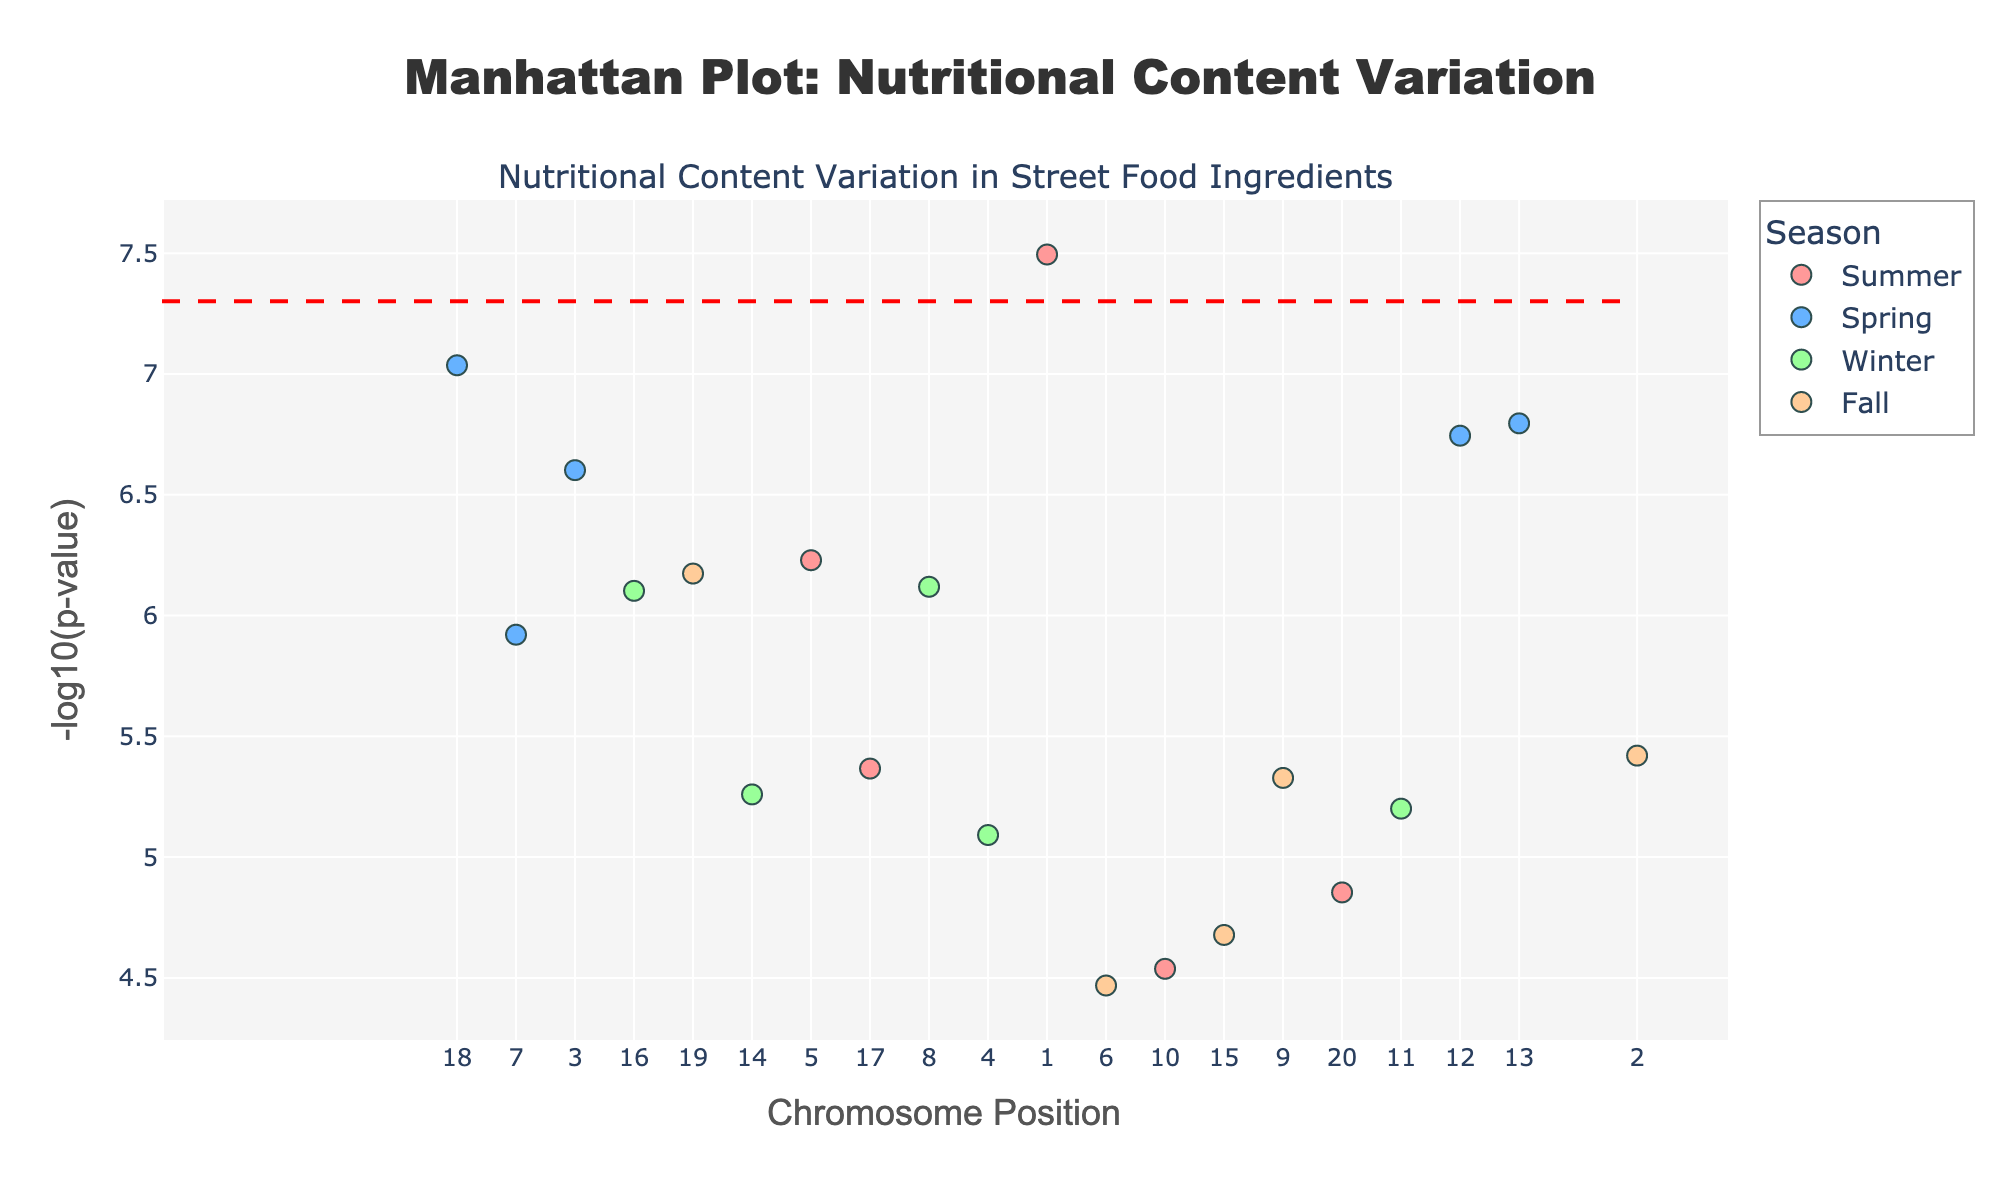How is the data categorized by seasons in the plot? The plot categorizes the data by seasons and assigns different colors to each season. This helps in visually distinguishing the data points of Tomatoes, Lettuce, Onions, etc., across Summer, Spring, Winter, and Fall.
Answer: By colors What is the highest -log10(p-value) observed in the plot and for which ingredient? The highest -log10(p-value) is the data point that appears highest on the y-axis of the plot. Observing the plot, this highest point corresponds to Tomatoes in Summer.
Answer: Tomatoes Which season has the most significant variation (lowest p-value) in nutritional content? The significance of variation is determined by the p-value, with lower p-values being more significant. Observing the plot, the lowest p-value corresponds to Tomatoes in Summer, and summer data points appear more frequently among the highly significant points.
Answer: Summer What does the red dashed line on the plot represent? The red dashed line is typically a significance threshold in Manhattan plots, indicating the p-value below which points are considered to be statistically significant. The plot shows this threshold line at -log10(5e-8).
Answer: Significance threshold How does the significance of the variation of Garlic in Spring compare to Cilantro in Fall? By comparing the heights of the points representing Garlic in Spring and Cilantro in Fall, we can see that Garlic in Spring (higher -log10(p-value)) is more significant than Cilantro in Fall (lower -log10(p-value)).
Answer: Garlic in Spring What is the total number of ingredients that exceed the significance threshold? Points exceeding the significance threshold can be counted visually above the red dashed line. By counting these points in the plot, we can observe how much of the nutritional variation is significant.
Answer: 3 ingredients Which season has the fewest data points? Each point on the plot is color-coded by season. By counting the number of points for each color, we can determine which season is represented the least.
Answer: Fall What ingredient, appearing in the plot, is closest to the significance threshold? Observing the points that are nearest to the red dashed line representing the significance threshold, Onion in Winter appears closest to this line.
Answer: Onion in Winter Considering Cucumbers in Summer and Eggplant in Fall, which has a more significant nutritional content variation? By comparing the vertical positions of the points representing Cucumbers in Summer and Eggplant in Fall, Cucumbers in Summer is higher and therefore more significant.
Answer: Cucumbers in Summer 